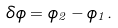<formula> <loc_0><loc_0><loc_500><loc_500>\delta \phi = \phi _ { 2 } - \phi _ { 1 } .</formula> 